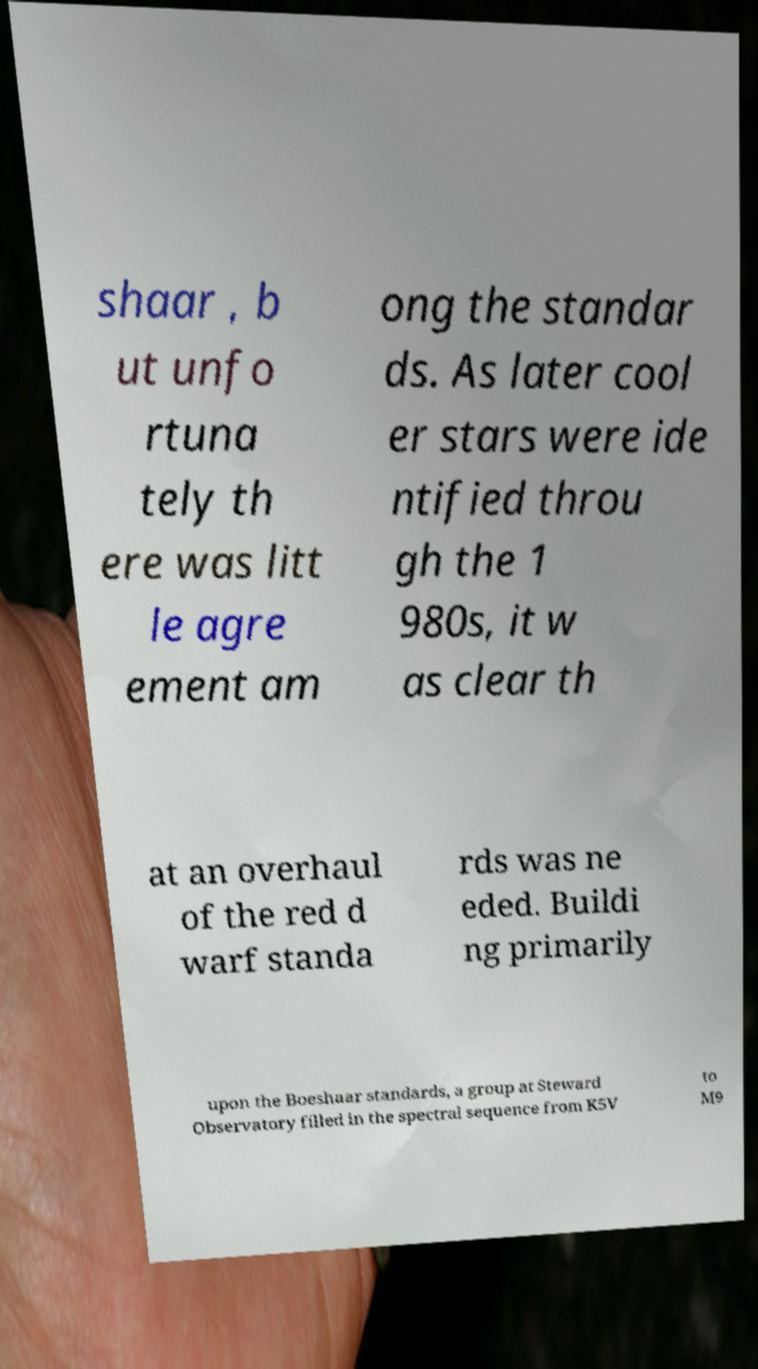Can you accurately transcribe the text from the provided image for me? shaar , b ut unfo rtuna tely th ere was litt le agre ement am ong the standar ds. As later cool er stars were ide ntified throu gh the 1 980s, it w as clear th at an overhaul of the red d warf standa rds was ne eded. Buildi ng primarily upon the Boeshaar standards, a group at Steward Observatory filled in the spectral sequence from K5V to M9 